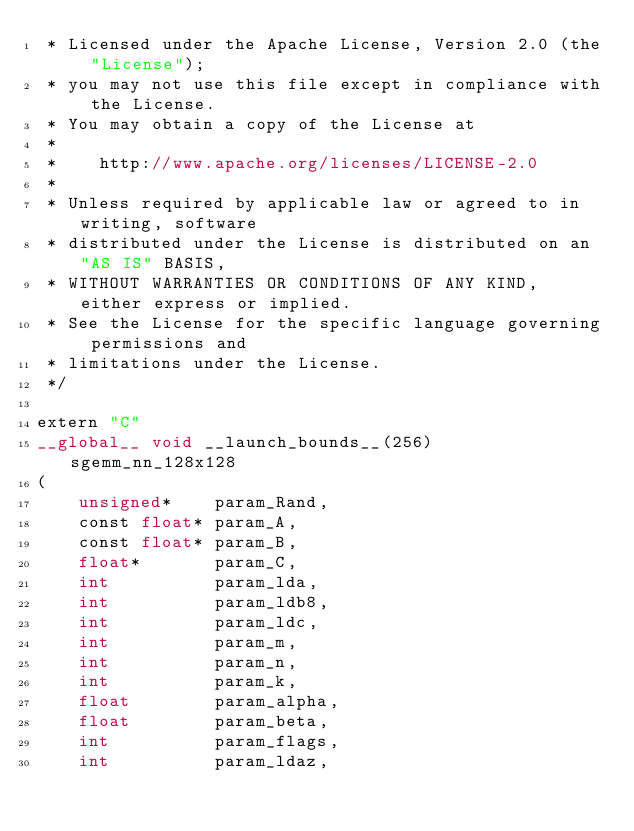Convert code to text. <code><loc_0><loc_0><loc_500><loc_500><_Cuda_> * Licensed under the Apache License, Version 2.0 (the "License");
 * you may not use this file except in compliance with the License.
 * You may obtain a copy of the License at
 * 
 *    http://www.apache.org/licenses/LICENSE-2.0
 * 
 * Unless required by applicable law or agreed to in writing, software
 * distributed under the License is distributed on an "AS IS" BASIS,
 * WITHOUT WARRANTIES OR CONDITIONS OF ANY KIND, either express or implied.
 * See the License for the specific language governing permissions and
 * limitations under the License.
 */

extern "C"
__global__ void __launch_bounds__(256) sgemm_nn_128x128
(
    unsigned*    param_Rand,
    const float* param_A,
    const float* param_B,
    float*       param_C,
    int          param_lda,  
    int          param_ldb8,  
    int          param_ldc,
    int          param_m,
    int          param_n,
    int          param_k,
    float        param_alpha,
    float        param_beta,
    int          param_flags,
    int          param_ldaz,</code> 